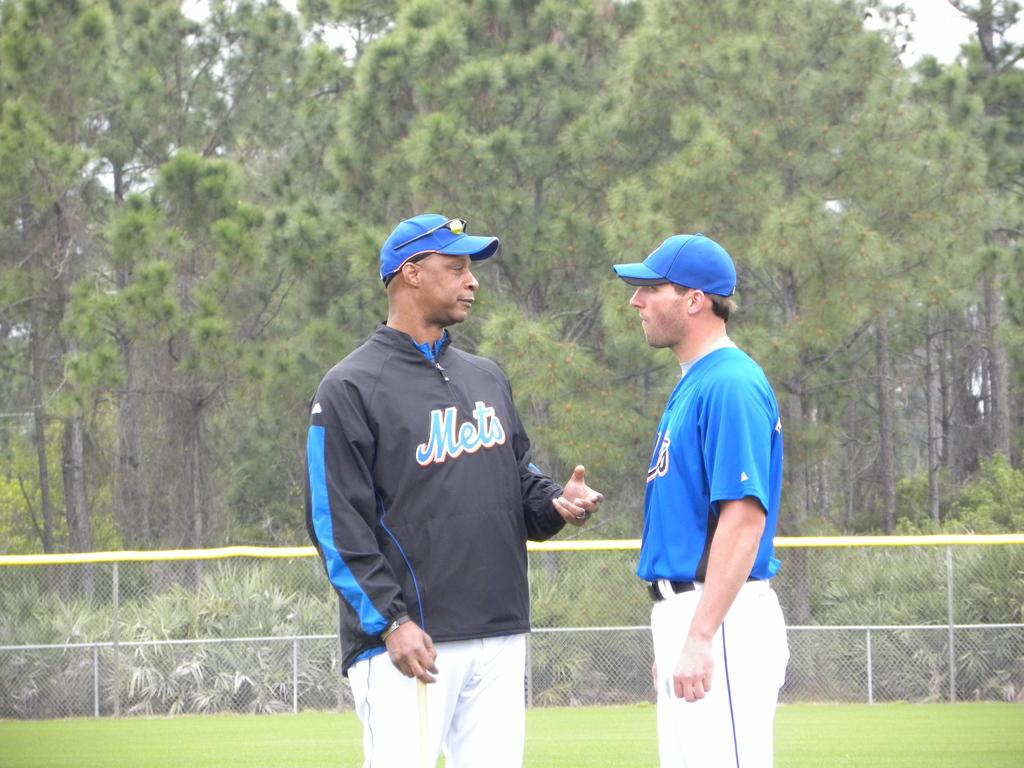<image>
Present a compact description of the photo's key features. A  man in a Mets windbreaker is talking to a man in a Mets jersey. 